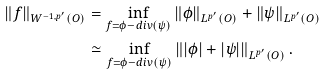Convert formula to latex. <formula><loc_0><loc_0><loc_500><loc_500>\| f \| _ { W ^ { - 1 , p ^ { \prime } } ( O ) } & = \inf _ { f = \phi - d i v ( \psi ) } \left \| \phi \right \| _ { L ^ { p ^ { \prime } } ( O ) } + \left \| \psi \right \| _ { L ^ { p ^ { \prime } } ( O ) } \\ & \simeq \inf _ { f = \phi - d i v ( \psi ) } \left \| | \phi | + | \psi | \right \| _ { L ^ { p ^ { \prime } } ( O ) } .</formula> 